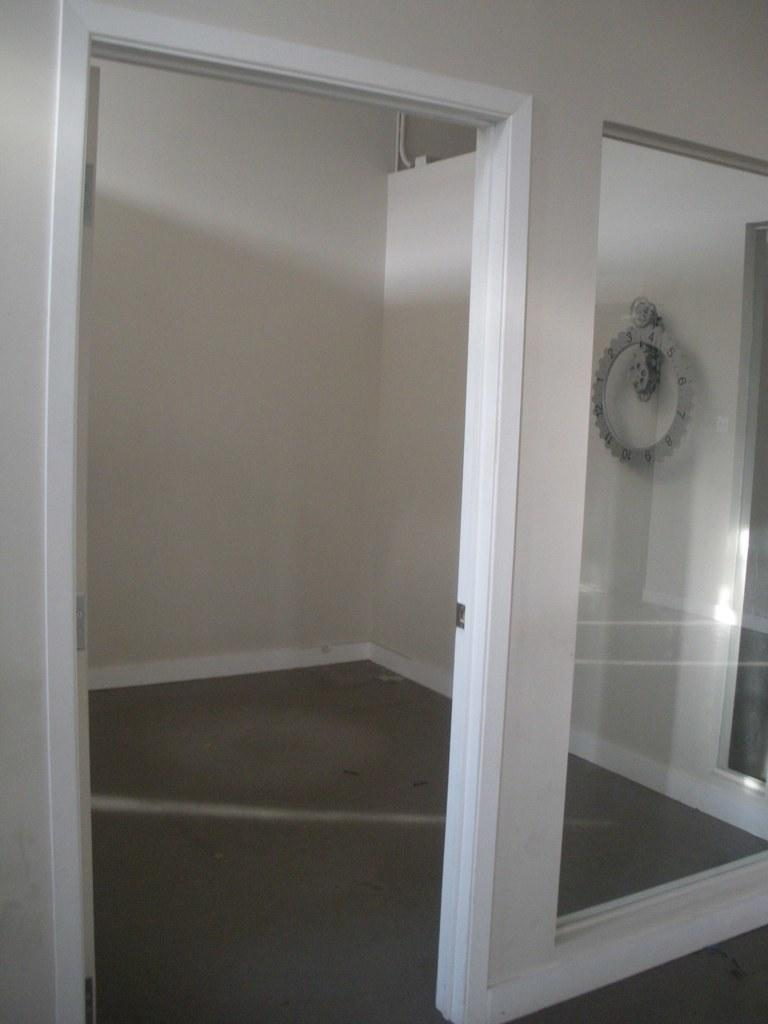What is the main feature of the image? There is an entrance into a room in the image. What can be seen on the right side of the image? There is a glass on the right side of the image. What color is the wall in the background of the image? There is a white color wall in the background of the image. What type of appliance can be seen in the cave in the image? There is no cave or appliance present in the image. 